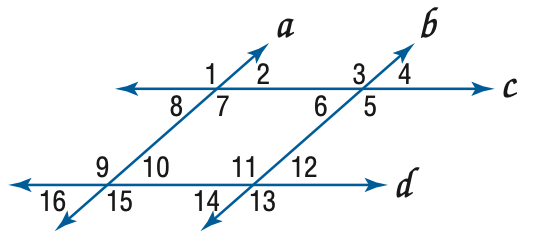Question: In the figure, a \parallel b, c \parallel d, and m \angle 4 = 57. Find the measure of \angle 10.
Choices:
A. 57
B. 113
C. 123
D. 133
Answer with the letter. Answer: A 